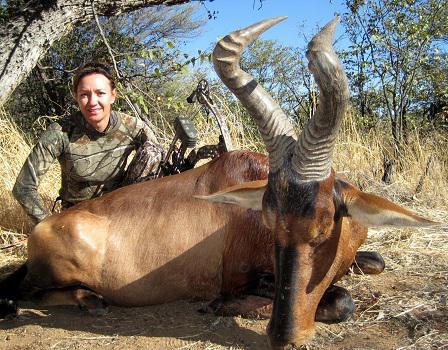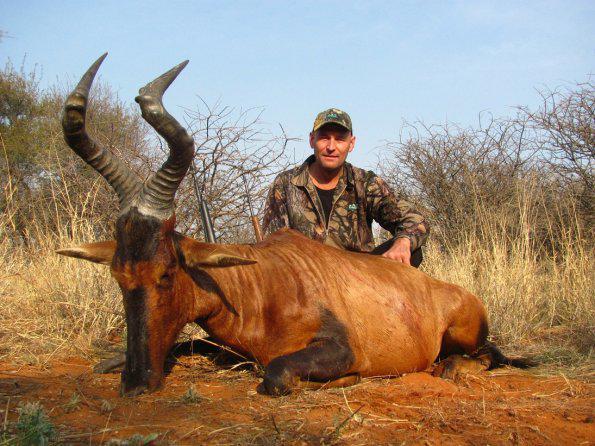The first image is the image on the left, the second image is the image on the right. Evaluate the accuracy of this statement regarding the images: "In the right image, a hunter in a brimmed hat holding a rifle vertically is behind a downed horned animal with its head to the right.". Is it true? Answer yes or no. No. 